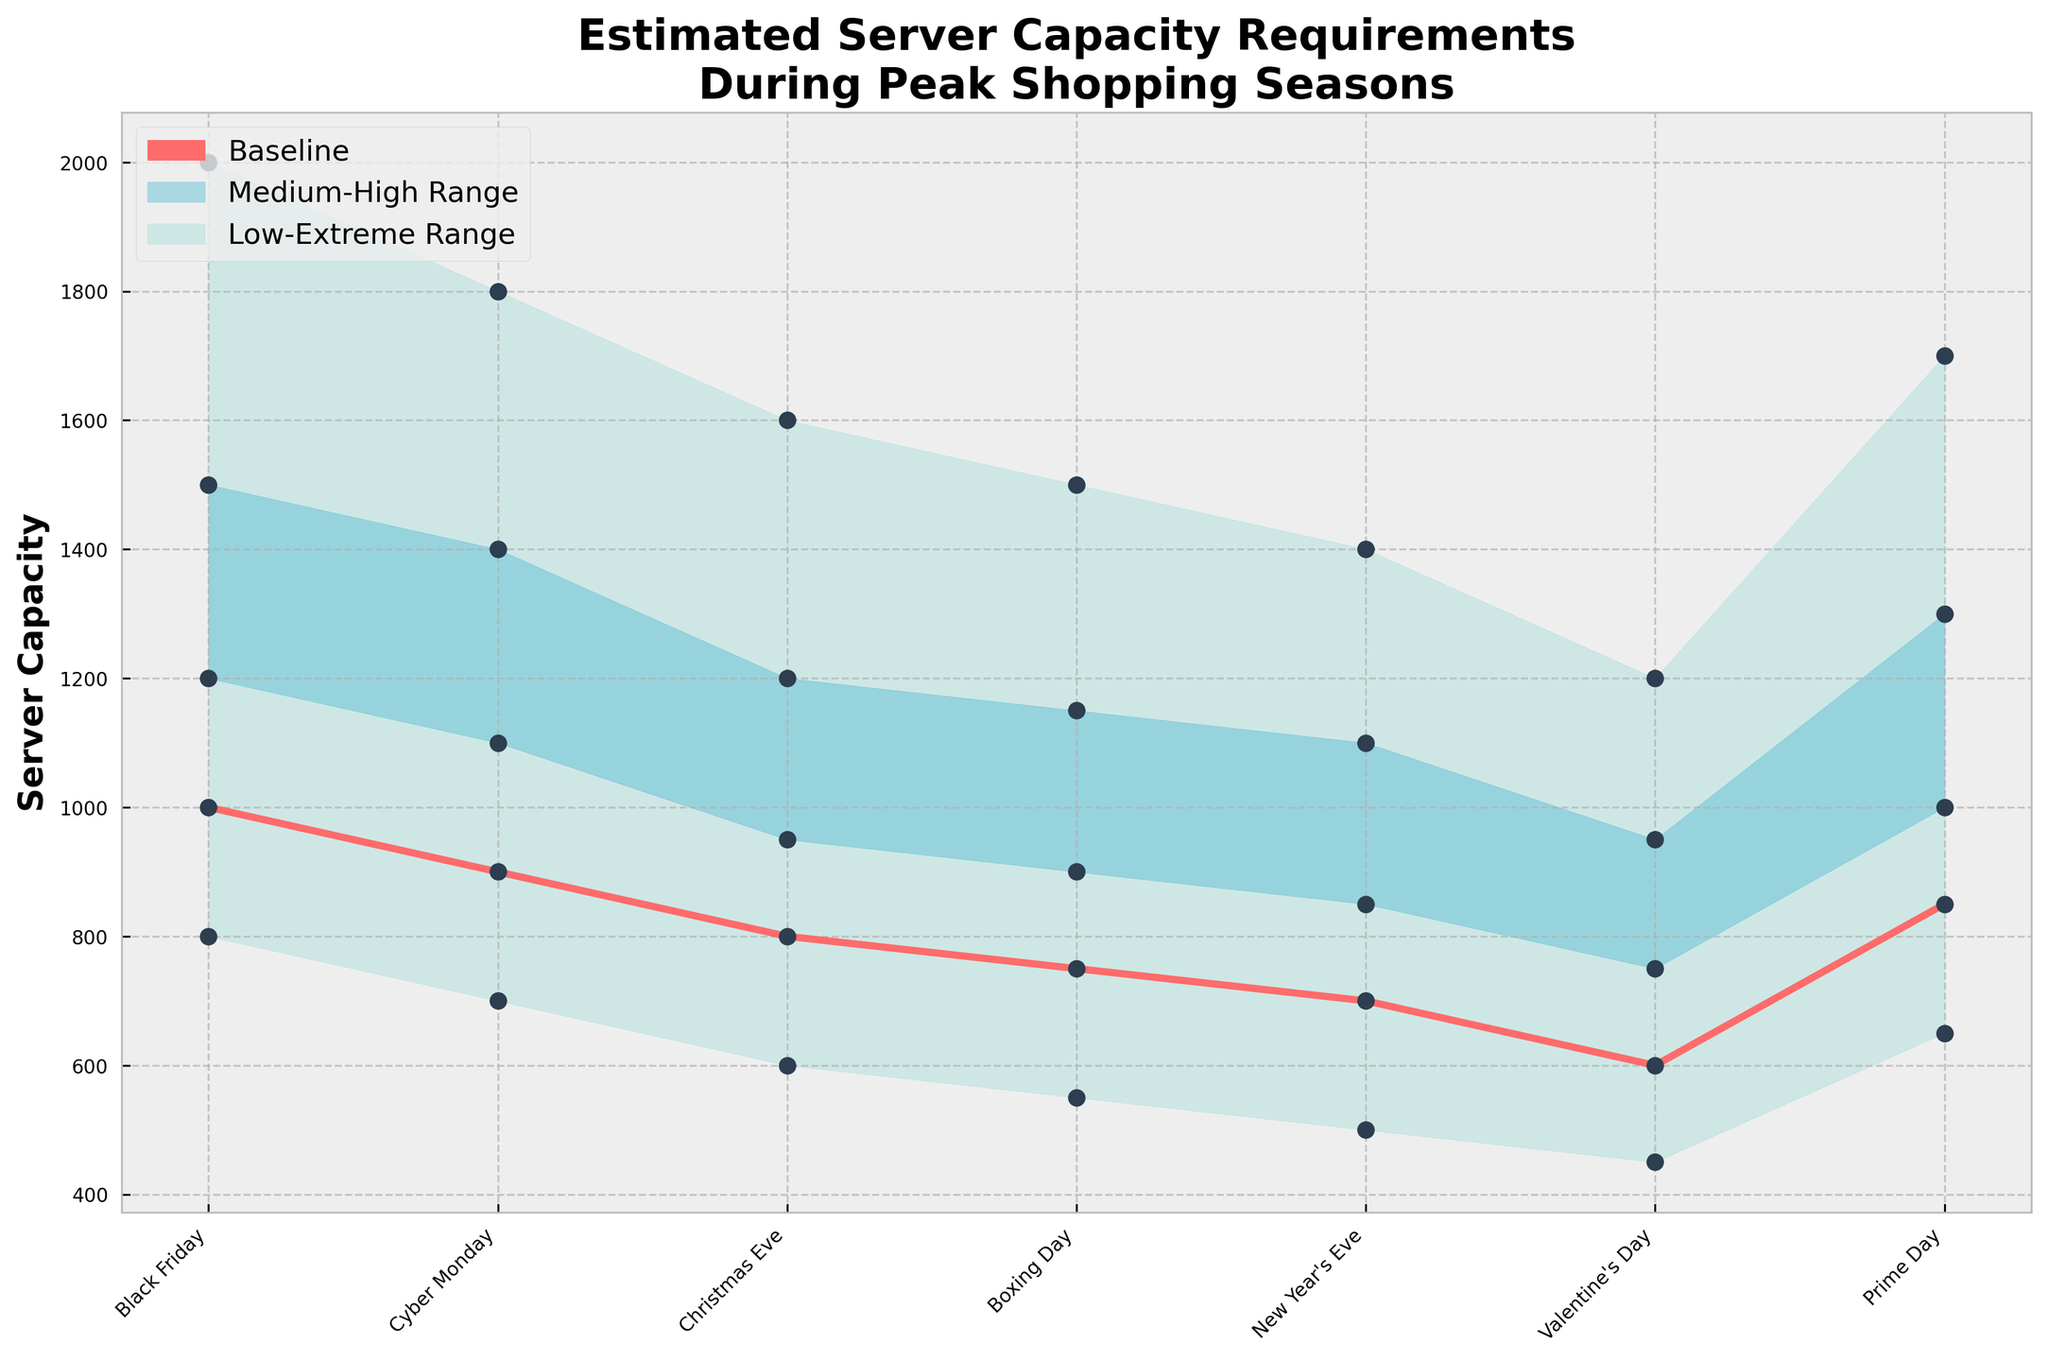What is the title of the chart? The title of the chart is found at the top of the figure, presented in a larger and bold font.
Answer: Estimated Server Capacity Requirements During Peak Shopping Seasons How many peak shopping seasons are displayed in the chart? The X-axis labels represent the different peak shopping seasons, and there are seven labels. Count the labels: Black Friday, Cyber Monday, Christmas Eve, Boxing Day, New Year's Eve, Valentine's Day, and Prime Day.
Answer: 7 Which peak shopping season has the highest baseline server capacity requirement? The baseline series is plotted in a distinct color. Compare the values of the baseline series for each season and find the highest one. Black Friday has the highest baseline value at 1000.
Answer: Black Friday What is the range of server capacity requirements for Cyber Monday? For Cyber Monday, observe the vertical span covered by the fan chart from the 'Low' to the 'Extreme' scenario. The capacity requirements range from 700 (Low) to 1800 (Extreme).
Answer: 700 to 1800 On which date is the baseline server capacity requirement the lowest? Look at the baseline series and find the minimum point. Valentine's Day has the lowest baseline requirement at 600.
Answer: Valentine's Day By how much does the extreme scenario for Black Friday exceed the baseline? Subtract the baseline value (1000) from the extreme scenario value (2000) for Black Friday to find the difference. 2000 - 1000 = 1000.
Answer: 1000 How does the medium scenario for Christmas Eve compare to the high scenario for Boxing Day? Identify the medium value for Christmas Eve and the high value for Boxing Day from the chart. The medium value for Christmas Eve is 950, and the high value for Boxing Day is 1150. Compare the two values.
Answer: The medium for Christmas Eve is less than the high for Boxing Day What are the server capacity values for New Year's Eve across different scenarios? Look at New Year's Eve's position on the X-axis and locate the values for the Low, Medium, High, and Extreme scenarios. Low: 500, Medium: 850, High: 1100, Extreme: 1400.
Answer: Low: 500, Medium: 850, High: 1100, Extreme: 1400 Which scenario has the widest range of server capacity requirements, and what is the range? Calculate the range for each scenario by subtracting the Low value from the Extreme value and find the widest range. Black Friday has the range from 800 (Low) to 2000 (Extreme), which is a range of 1200.
Answer: Black Friday; 1200 